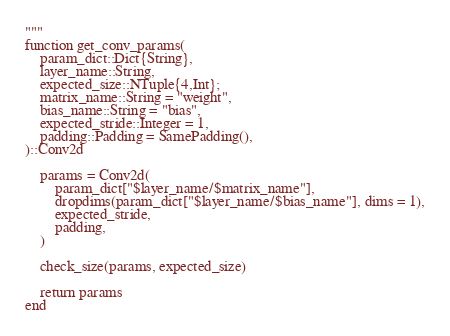<code> <loc_0><loc_0><loc_500><loc_500><_Julia_>"""
function get_conv_params(
    param_dict::Dict{String},
    layer_name::String,
    expected_size::NTuple{4,Int};
    matrix_name::String = "weight",
    bias_name::String = "bias",
    expected_stride::Integer = 1,
    padding::Padding = SamePadding(),
)::Conv2d

    params = Conv2d(
        param_dict["$layer_name/$matrix_name"],
        dropdims(param_dict["$layer_name/$bias_name"], dims = 1),
        expected_stride,
        padding,
    )

    check_size(params, expected_size)

    return params
end
</code> 